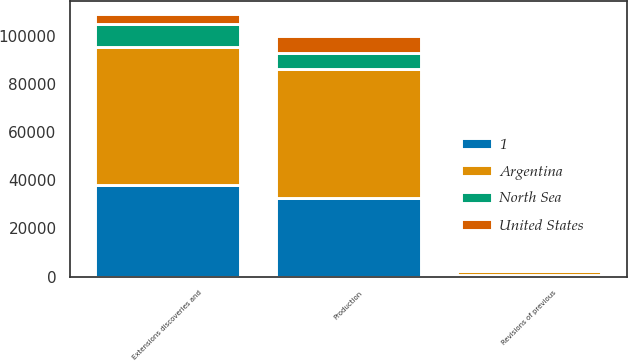Convert chart. <chart><loc_0><loc_0><loc_500><loc_500><stacked_bar_chart><ecel><fcel>Revisions of previous<fcel>Production<fcel>Extensions discoveries and<nl><fcel>Argentina<fcel>1683<fcel>53621<fcel>57011<nl><fcel>North Sea<fcel>531<fcel>6469<fcel>9657<nl><fcel>1<fcel>457<fcel>32690<fcel>38074<nl><fcel>United States<fcel>118<fcel>7055<fcel>4254<nl></chart> 